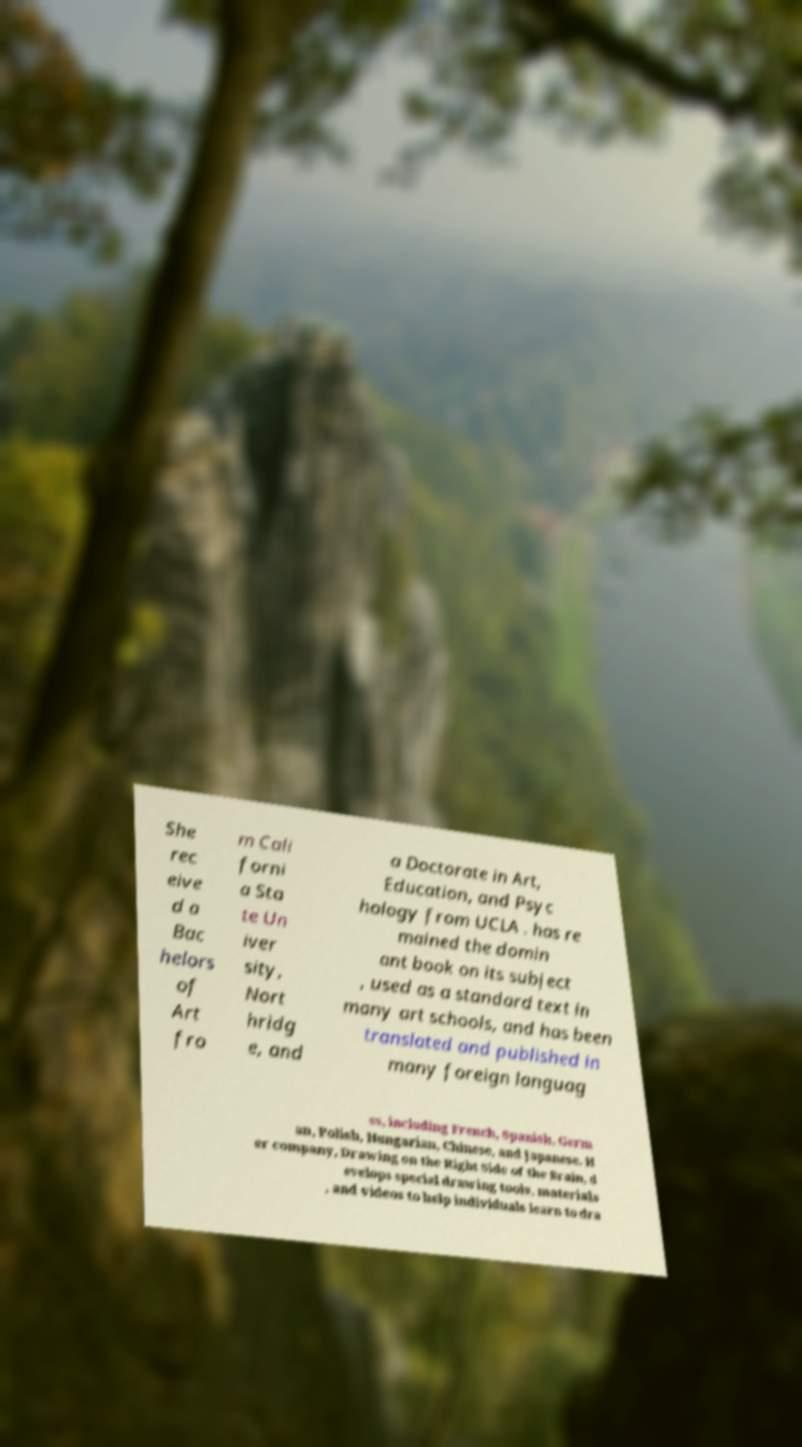Could you extract and type out the text from this image? She rec eive d a Bac helors of Art fro m Cali forni a Sta te Un iver sity, Nort hridg e, and a Doctorate in Art, Education, and Psyc hology from UCLA . has re mained the domin ant book on its subject , used as a standard text in many art schools, and has been translated and published in many foreign languag es, including French, Spanish, Germ an, Polish, Hungarian, Chinese, and Japanese. H er company, Drawing on the Right Side of the Brain, d evelops special drawing tools, materials , and videos to help individuals learn to dra 